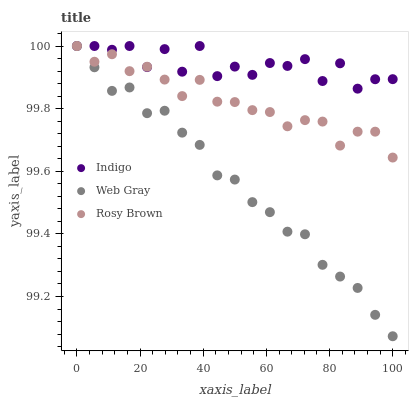Does Web Gray have the minimum area under the curve?
Answer yes or no. Yes. Does Indigo have the maximum area under the curve?
Answer yes or no. Yes. Does Indigo have the minimum area under the curve?
Answer yes or no. No. Does Web Gray have the maximum area under the curve?
Answer yes or no. No. Is Web Gray the smoothest?
Answer yes or no. Yes. Is Indigo the roughest?
Answer yes or no. Yes. Is Indigo the smoothest?
Answer yes or no. No. Is Web Gray the roughest?
Answer yes or no. No. Does Web Gray have the lowest value?
Answer yes or no. Yes. Does Indigo have the lowest value?
Answer yes or no. No. Does Indigo have the highest value?
Answer yes or no. Yes. Does Rosy Brown intersect Web Gray?
Answer yes or no. Yes. Is Rosy Brown less than Web Gray?
Answer yes or no. No. Is Rosy Brown greater than Web Gray?
Answer yes or no. No. 